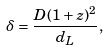Convert formula to latex. <formula><loc_0><loc_0><loc_500><loc_500>\delta = \frac { D ( 1 + z ) ^ { 2 } } { d _ { L } } ,</formula> 